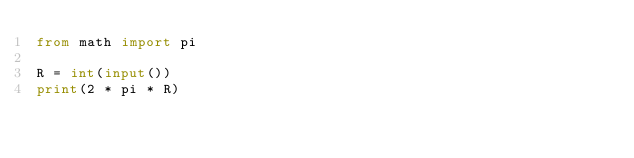Convert code to text. <code><loc_0><loc_0><loc_500><loc_500><_Python_>from math import pi

R = int(input())
print(2 * pi * R)
</code> 